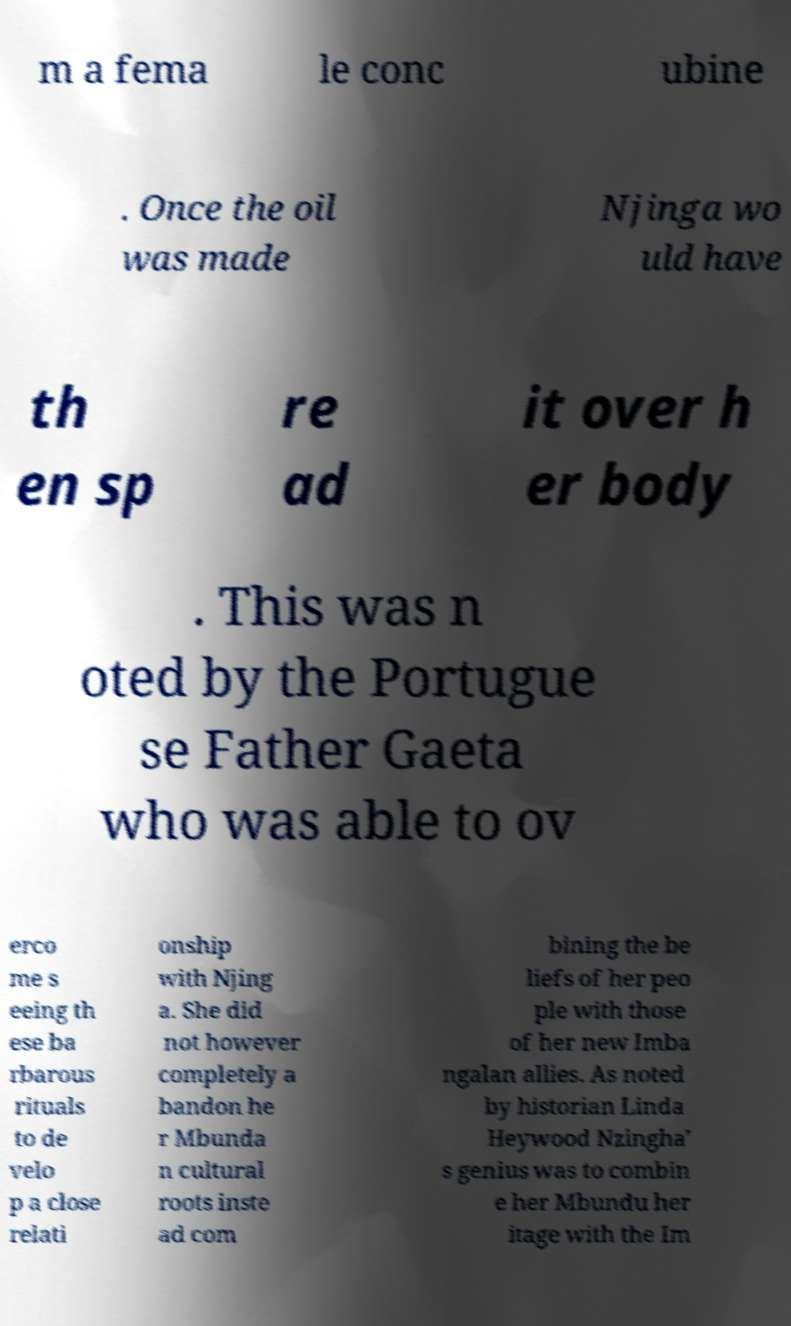Could you extract and type out the text from this image? m a fema le conc ubine . Once the oil was made Njinga wo uld have th en sp re ad it over h er body . This was n oted by the Portugue se Father Gaeta who was able to ov erco me s eeing th ese ba rbarous rituals to de velo p a close relati onship with Njing a. She did not however completely a bandon he r Mbunda n cultural roots inste ad com bining the be liefs of her peo ple with those of her new Imba ngalan allies. As noted by historian Linda Heywood Nzingha' s genius was to combin e her Mbundu her itage with the Im 